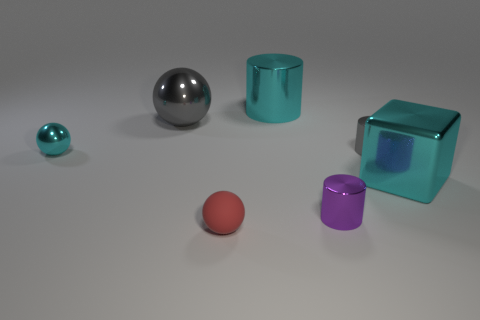There is a block that is the same color as the small metal sphere; what size is it?
Give a very brief answer. Large. What number of blocks are tiny red things or gray things?
Provide a short and direct response. 0. Do the red matte thing and the big gray object have the same shape?
Offer a very short reply. Yes. What is the size of the cylinder that is behind the big gray shiny ball?
Ensure brevity in your answer.  Large. Are there any tiny metallic objects that have the same color as the big shiny ball?
Ensure brevity in your answer.  Yes. Does the cylinder that is in front of the block have the same size as the large cylinder?
Provide a short and direct response. No. The matte object has what color?
Offer a very short reply. Red. There is a large thing in front of the cyan shiny object to the left of the big sphere; what color is it?
Offer a very short reply. Cyan. Are there any gray objects made of the same material as the cyan cube?
Your answer should be very brief. Yes. What material is the red object in front of the big cyan object that is on the left side of the purple object?
Your response must be concise. Rubber. 